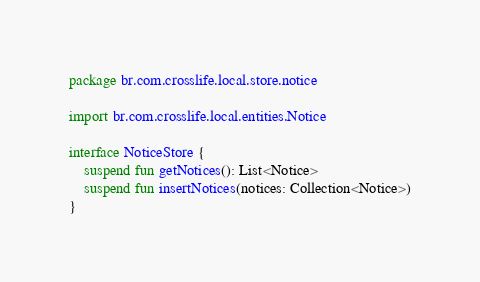Convert code to text. <code><loc_0><loc_0><loc_500><loc_500><_Kotlin_>package br.com.crosslife.local.store.notice

import br.com.crosslife.local.entities.Notice

interface NoticeStore {
    suspend fun getNotices(): List<Notice>
    suspend fun insertNotices(notices: Collection<Notice>)
}
</code> 